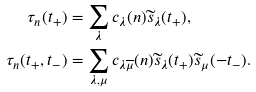<formula> <loc_0><loc_0><loc_500><loc_500>\tau _ { n } ( t _ { + } ) & = \sum _ { \lambda } c _ { \lambda } ( n ) \widetilde { s } _ { \lambda } ( t _ { + } ) , \\ \tau _ { n } ( t _ { + } , t _ { - } ) & = \sum _ { \lambda , \mu } c _ { \lambda \overline { \mu } } ( n ) \widetilde { s } _ { \lambda } ( t _ { + } ) \widetilde { s } _ { \mu } ( - t _ { - } ) .</formula> 